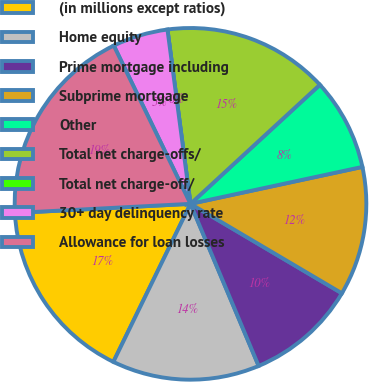<chart> <loc_0><loc_0><loc_500><loc_500><pie_chart><fcel>(in millions except ratios)<fcel>Home equity<fcel>Prime mortgage including<fcel>Subprime mortgage<fcel>Other<fcel>Total net charge-offs/<fcel>Total net charge-off/<fcel>30+ day delinquency rate<fcel>Allowance for loan losses<nl><fcel>16.95%<fcel>13.56%<fcel>10.17%<fcel>11.86%<fcel>8.47%<fcel>15.25%<fcel>0.0%<fcel>5.09%<fcel>18.64%<nl></chart> 